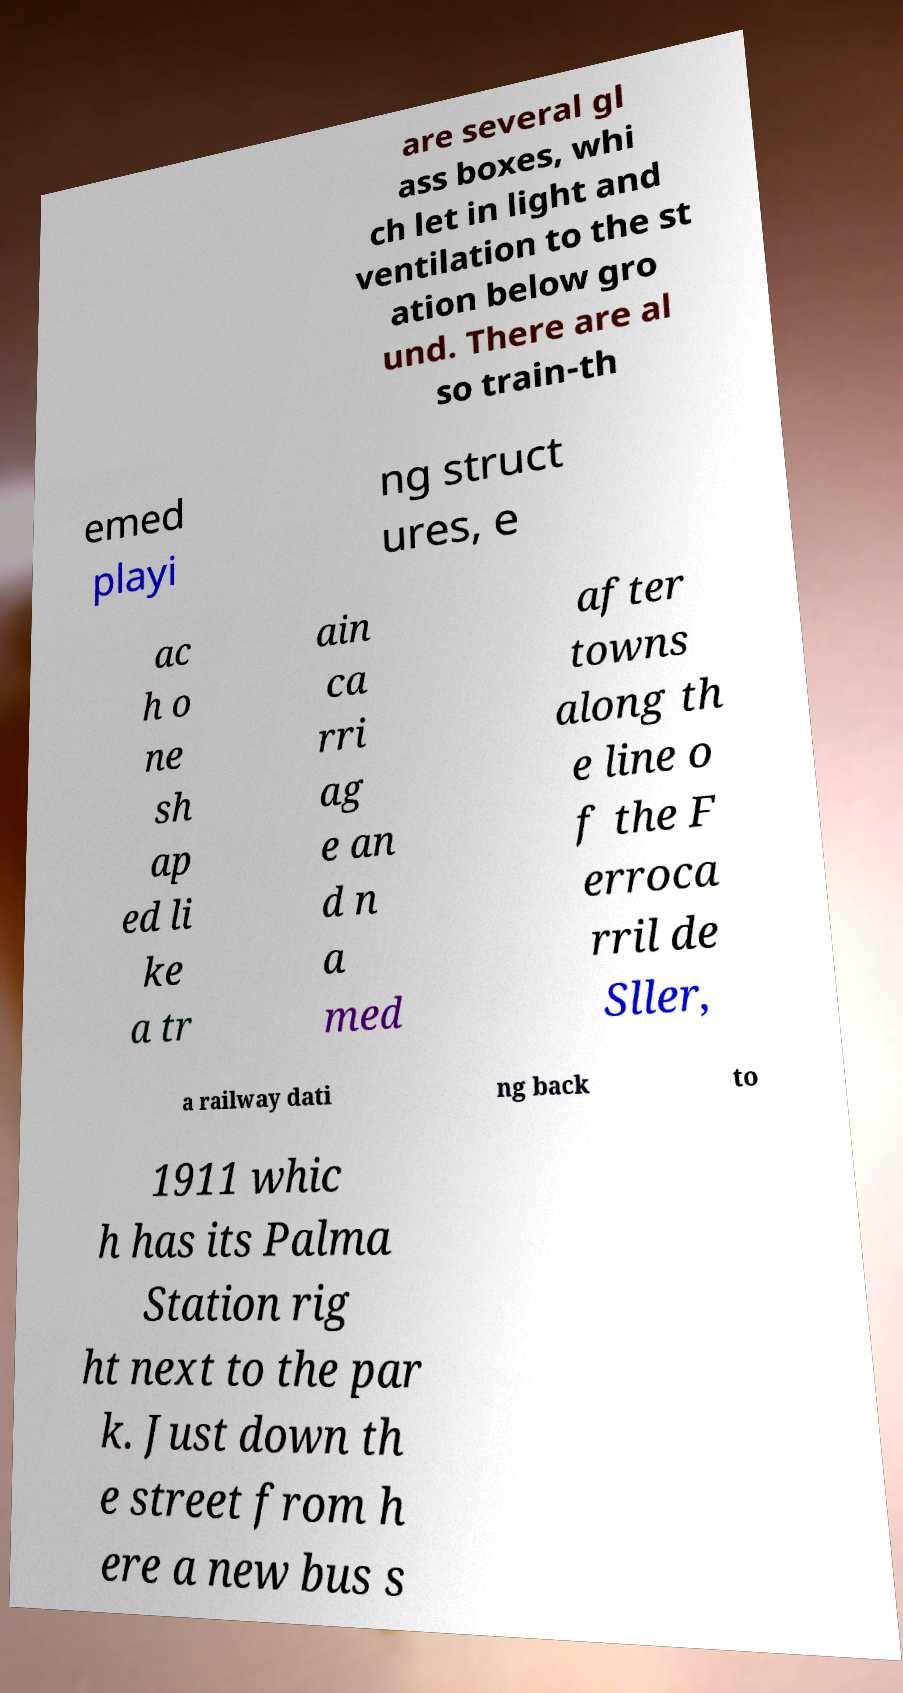For documentation purposes, I need the text within this image transcribed. Could you provide that? are several gl ass boxes, whi ch let in light and ventilation to the st ation below gro und. There are al so train-th emed playi ng struct ures, e ac h o ne sh ap ed li ke a tr ain ca rri ag e an d n a med after towns along th e line o f the F erroca rril de Sller, a railway dati ng back to 1911 whic h has its Palma Station rig ht next to the par k. Just down th e street from h ere a new bus s 